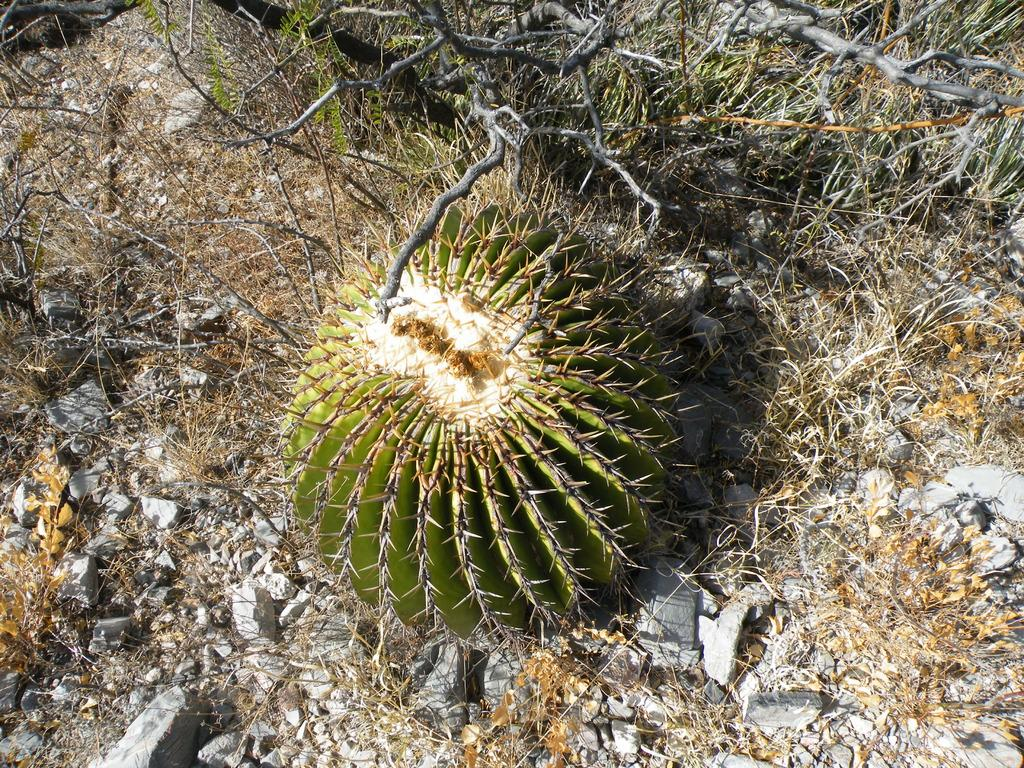What type of plant can be seen in the image? There is a cactus in the image. What other natural elements are present in the image? There are stones and grass in the image. Are there any other plants visible in the image? Yes, there are plants in the image. What type of secretary can be seen working in the image? There is no secretary present in the image; it features a cactus, stones, grass, and plants. What type of tail is visible on the plants in the image? There are no tails present on the plants in the image; they are simply plants. 